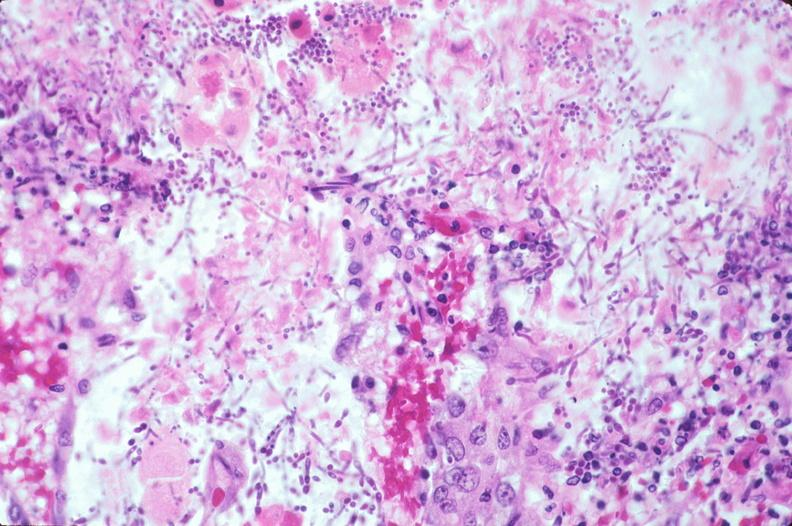where is this from?
Answer the question using a single word or phrase. Gastrointestinal system 